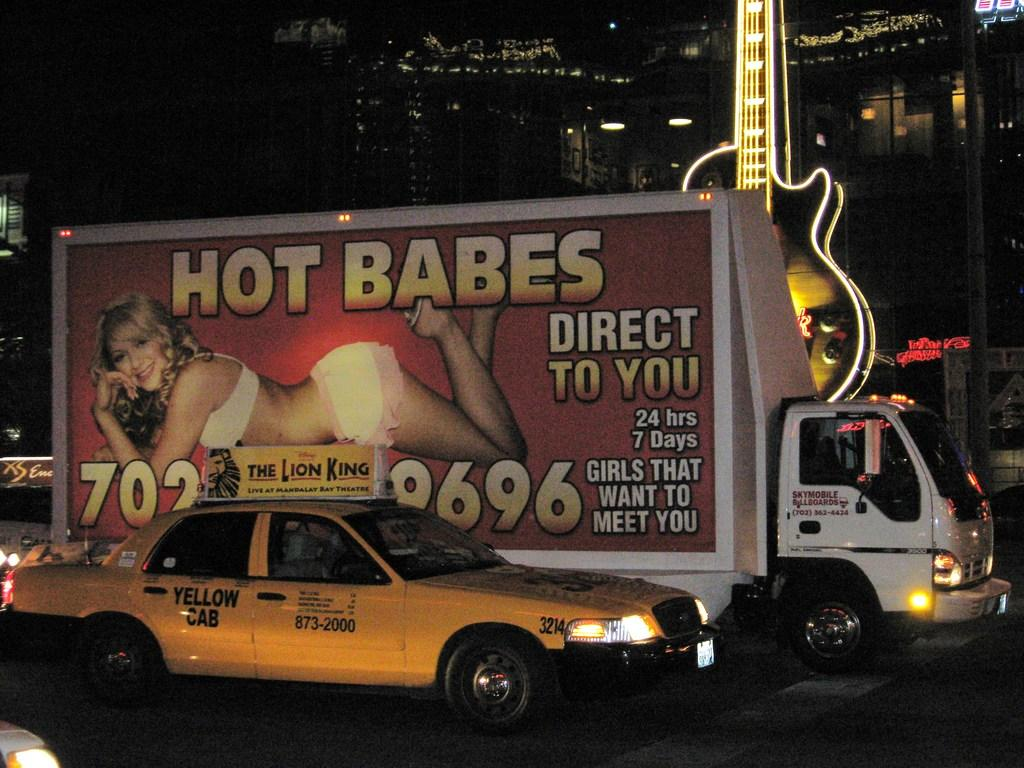<image>
Provide a brief description of the given image. The words of Hot Babes are on a side of a white truck beside a yellow cab. 